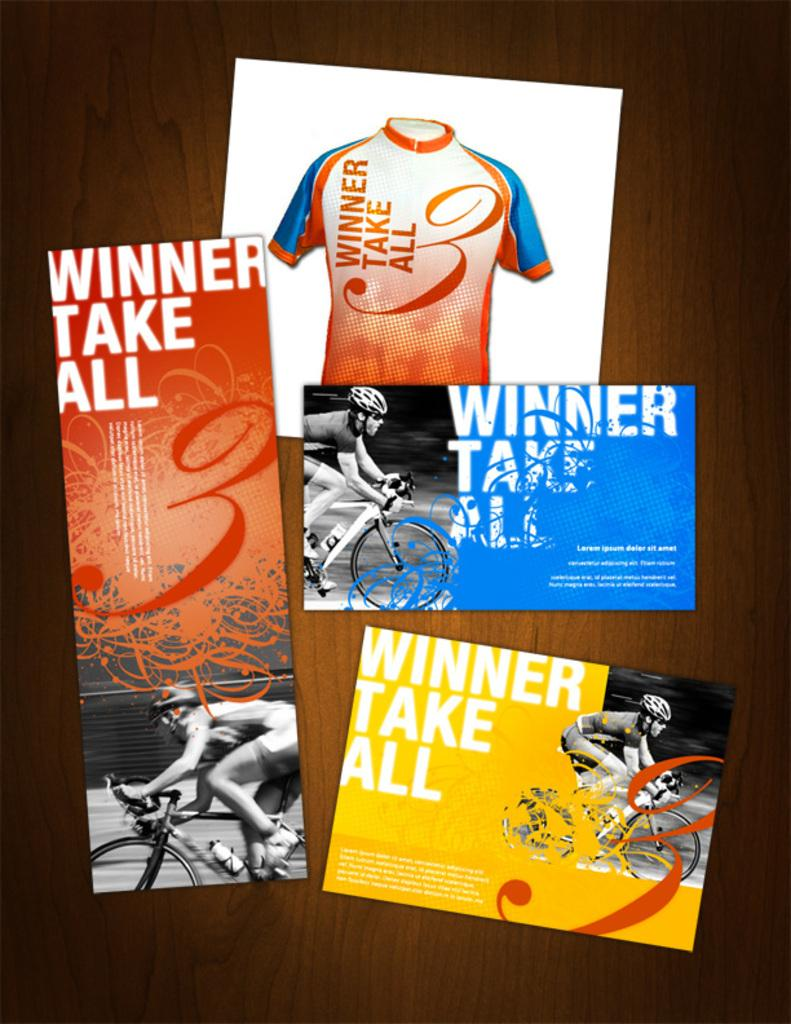<image>
Share a concise interpretation of the image provided. Marketing materials for cyclists that feature the winner take all motto 